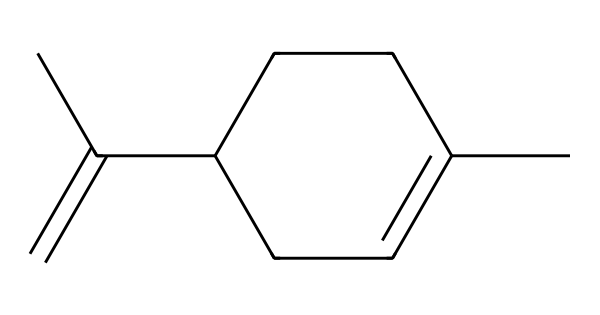How many carbon atoms are in limonene? By examining the SMILES representation, we can count the carbon (C) symbols. Here, there are a total of 10 carbon atoms present in the structure.
Answer: ten What type of compound is limonene? The structure features a continuous ring system and multiple double bonds, which classifies it as a cyclic monoterpene, specifically an aromatic compound due to its stable structure.
Answer: aromatic compound How many double bonds are present in the limonene structure? The SMILES notation shows that two double bonds are present, indicated by the 'C(=C)' and the double bond connections shown in the structure.
Answer: two Which part of the limonene structure contributes to its citrus scent? The presence of the cyclic structure and specific positioning of the double bonds in the carbon chain enables the characteristic citrus smell, which is largely associated with the functional groups present in limonene.
Answer: cyclic structure Is limonene considered a saturated or unsaturated compound? The double bonds in the carbon chain indicate that limonene has fewer hydrogen atoms than it would if all bonds were single, thus classifying it as an unsaturated compound.
Answer: unsaturated Does limonene have any functional groups? In the provided structure, limonene does not display any distinct functional groups such as hydroxyl or carboxyl, thus it mainly consists of hydrocarbons with a notable ring structure.
Answer: no 